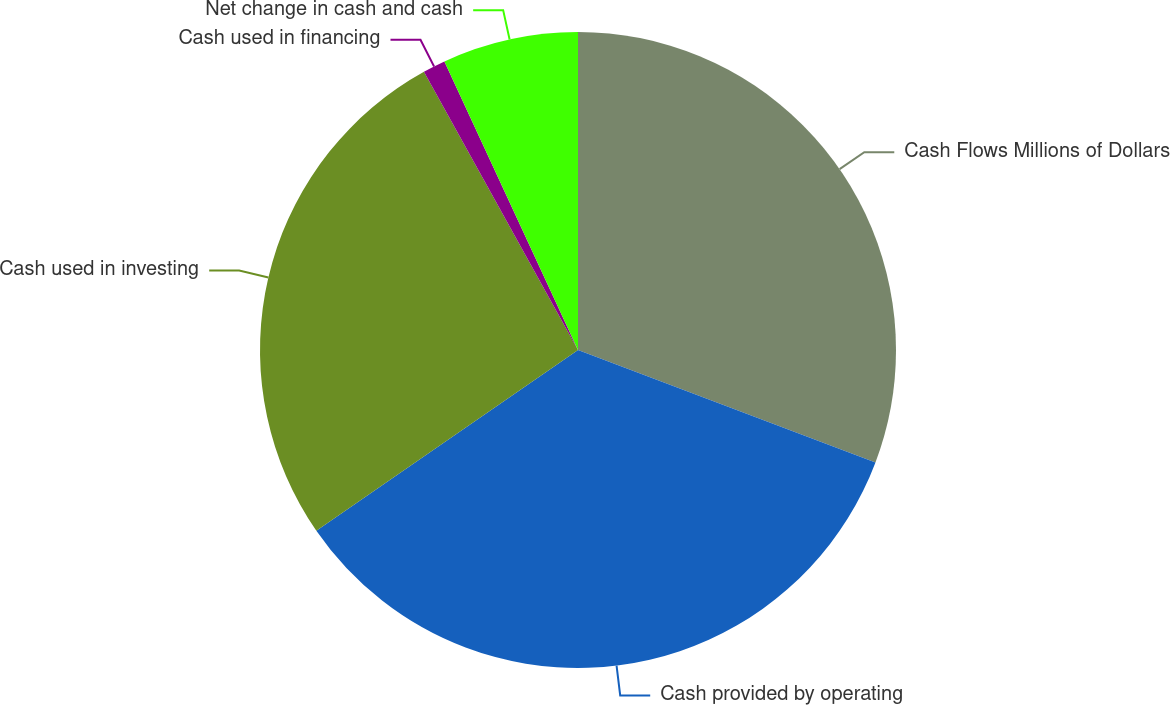<chart> <loc_0><loc_0><loc_500><loc_500><pie_chart><fcel>Cash Flows Millions of Dollars<fcel>Cash provided by operating<fcel>Cash used in investing<fcel>Cash used in financing<fcel>Net change in cash and cash<nl><fcel>30.75%<fcel>34.63%<fcel>26.57%<fcel>1.15%<fcel>6.9%<nl></chart> 